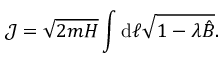<formula> <loc_0><loc_0><loc_500><loc_500>\mathcal { J } = \sqrt { 2 m H } \int d \ell \sqrt { 1 - \lambda \hat { B } } .</formula> 